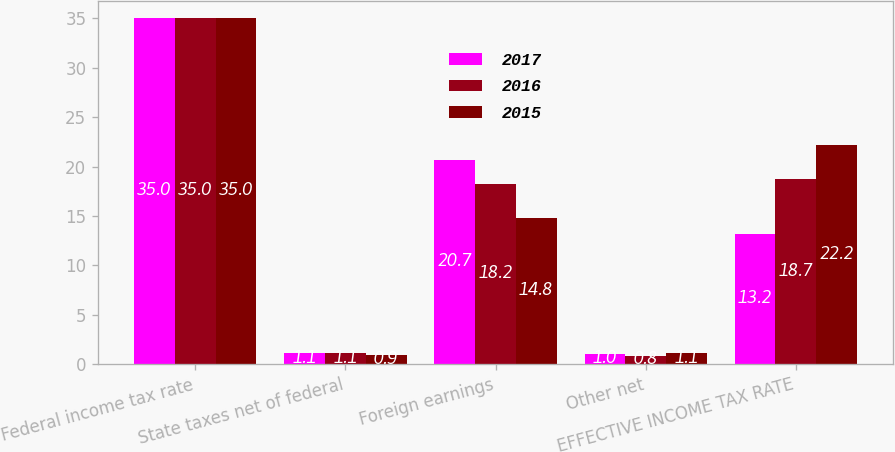<chart> <loc_0><loc_0><loc_500><loc_500><stacked_bar_chart><ecel><fcel>Federal income tax rate<fcel>State taxes net of federal<fcel>Foreign earnings<fcel>Other net<fcel>EFFECTIVE INCOME TAX RATE<nl><fcel>2017<fcel>35<fcel>1.1<fcel>20.7<fcel>1<fcel>13.2<nl><fcel>2016<fcel>35<fcel>1.1<fcel>18.2<fcel>0.8<fcel>18.7<nl><fcel>2015<fcel>35<fcel>0.9<fcel>14.8<fcel>1.1<fcel>22.2<nl></chart> 